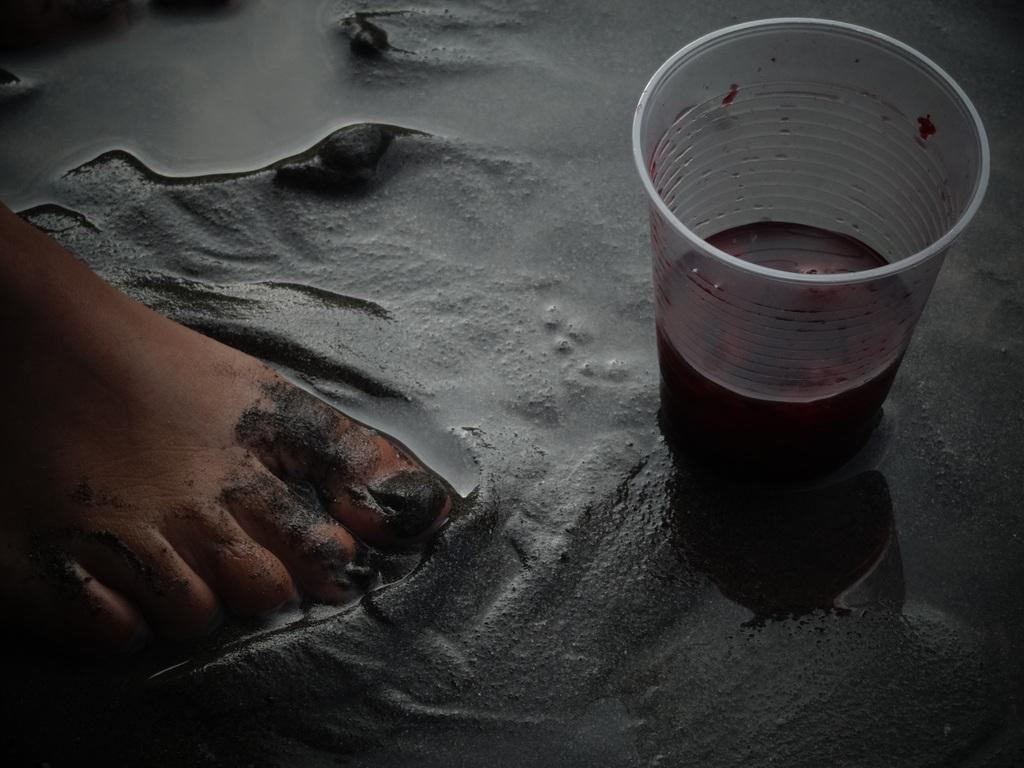Please provide a concise description of this image. In this image we can see there is a person's leg on the cement and there is a water and a cup with a drink. 